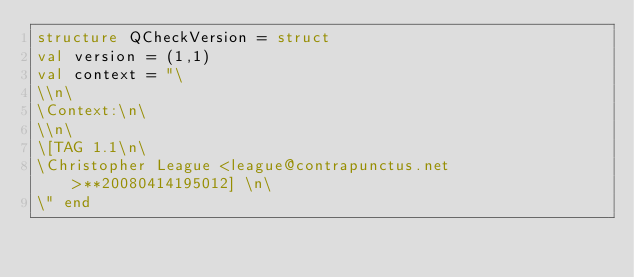<code> <loc_0><loc_0><loc_500><loc_500><_SML_>structure QCheckVersion = struct
val version = (1,1) 
val context = "\
\\n\
\Context:\n\
\\n\
\[TAG 1.1\n\
\Christopher League <league@contrapunctus.net>**20080414195012] \n\
\" end
</code> 